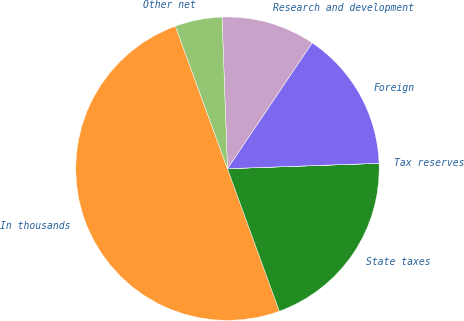Convert chart to OTSL. <chart><loc_0><loc_0><loc_500><loc_500><pie_chart><fcel>In thousands<fcel>State taxes<fcel>Tax reserves<fcel>Foreign<fcel>Research and development<fcel>Other net<nl><fcel>49.98%<fcel>20.0%<fcel>0.01%<fcel>15.0%<fcel>10.0%<fcel>5.01%<nl></chart> 